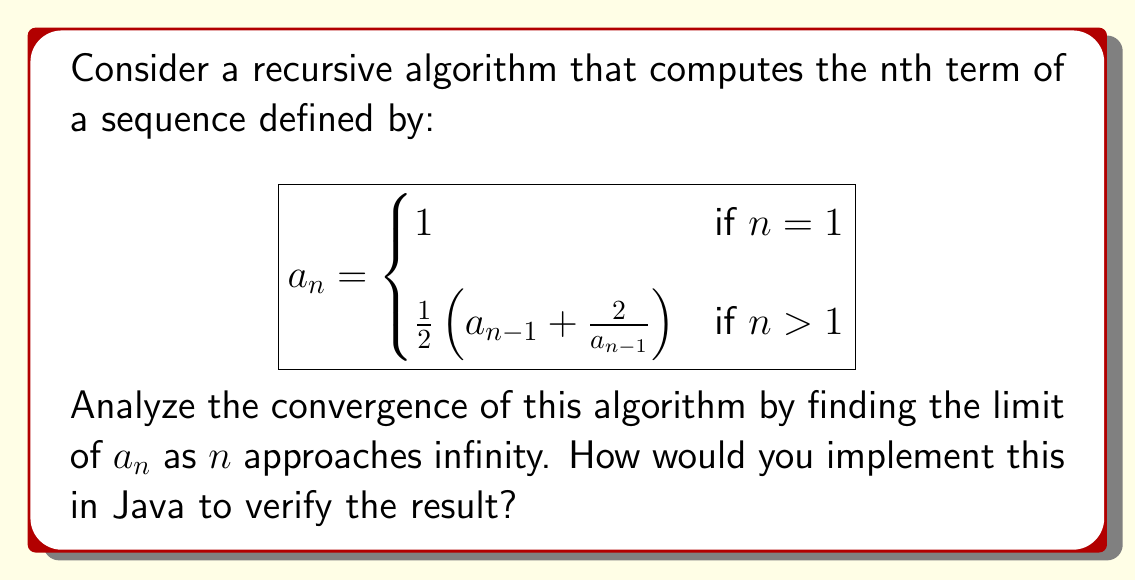Could you help me with this problem? To analyze the convergence of this recursive algorithm, we'll follow these steps:

1. Identify the limit:
Let $L = \lim_{n \to \infty} a_n$

2. If the sequence converges, then $L$ should satisfy:
$$L = \frac{1}{2}\left(L + \frac{2}{L}\right)$$

3. Solve this equation:
$$2L = L + \frac{2}{L}$$
$$L^2 = 2$$
$$L = \sqrt{2}$$ (we take the positive root as $a_n > 0$ for all $n$)

4. To prove convergence, we can show that this sequence is monotonic and bounded:

   a. Monotonicity: We can prove by induction that $a_n \geq \sqrt{2}$ for $n \geq 2$
   b. Upper bound: We can prove that $a_n \leq 2$ for all $n$

5. By the Monotone Convergence Theorem, the sequence converges to $\sqrt{2}$

To implement this in Java and verify the result:

```java
public class ConvergenceAnalysis {
    public static double recursiveSequence(int n) {
        if (n == 1) return 1;
        double prev = recursiveSequence(n - 1);
        return 0.5 * (prev + 2 / prev);
    }

    public static void main(String[] args) {
        int n = 20;
        double result = recursiveSequence(n);
        System.out.printf("a_%d = %.10f\n", n, result);
        System.out.printf("sqrt(2) = %.10f\n", Math.sqrt(2));
    }
}
```

This Java implementation will show that as $n$ increases, $a_n$ approaches $\sqrt{2}$.
Answer: The sequence converges to $\sqrt{2}$. 